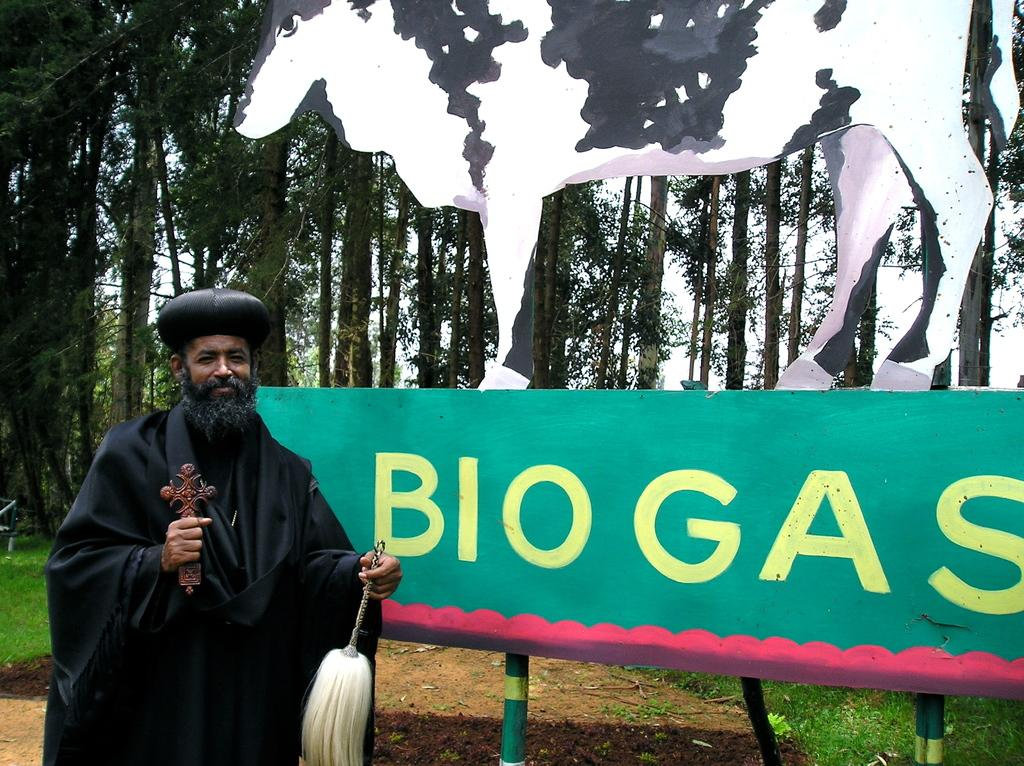What is the person standing beside in the image? The person is standing beside a board. What can be seen written on the board? The board has something written on it, which includes "bio gas." What kind of object is depicted on the board? There is a cow sculpture on the board. What can be seen in the background of the image? There are trees visible in the background of the image. What is the answer to the question written on the board in the image? There is no question present on the board in the image, so there is no answer to provide. 